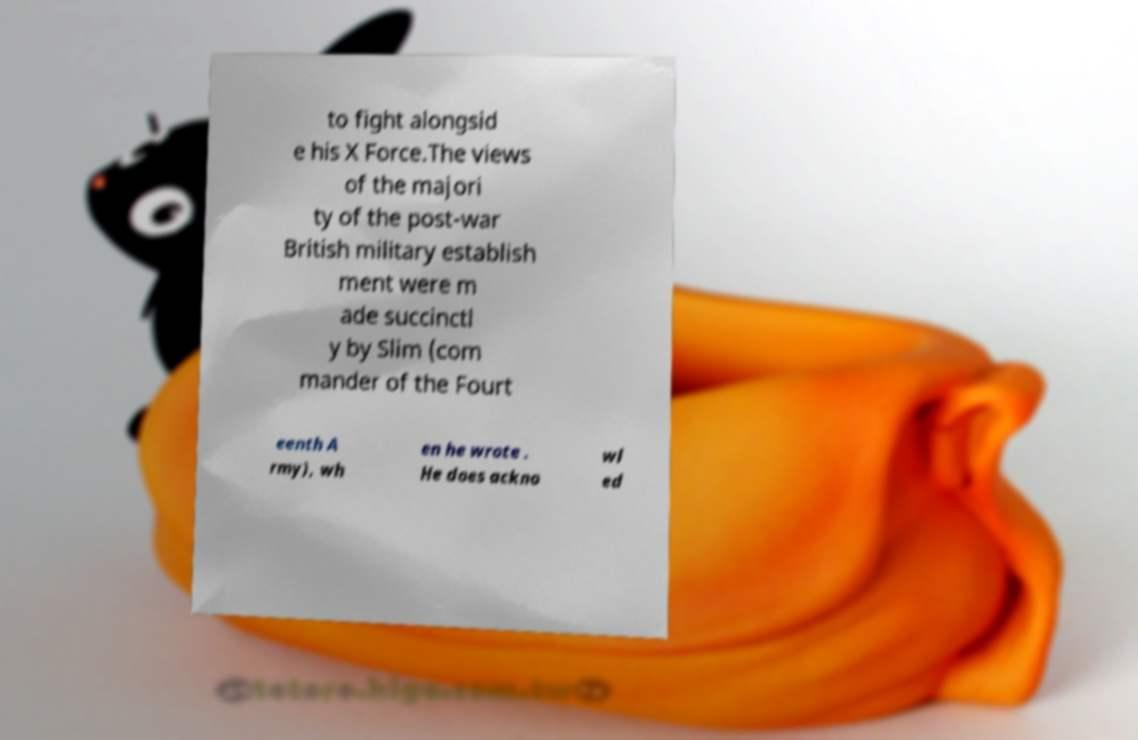Could you extract and type out the text from this image? to fight alongsid e his X Force.The views of the majori ty of the post-war British military establish ment were m ade succinctl y by Slim (com mander of the Fourt eenth A rmy), wh en he wrote . He does ackno wl ed 